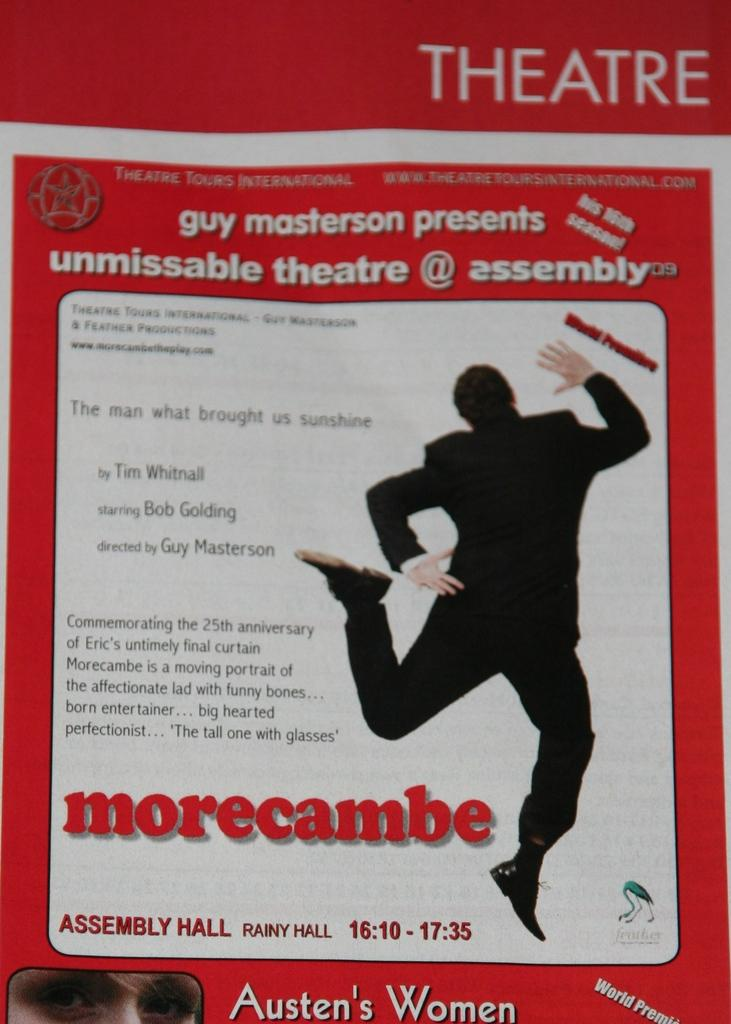What is the main subject of the image? The main subject of the image is an advertisement. Can you describe the person in the image? There is a person on the right side of the image. What else can be seen on the left side of the image? There is text on the left side of the image. What type of nail is being used by the person in the image? There is no nail visible in the image, and the person is not using any tool. 